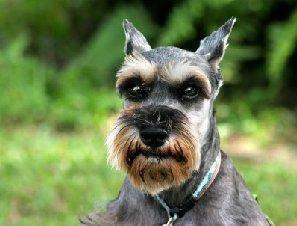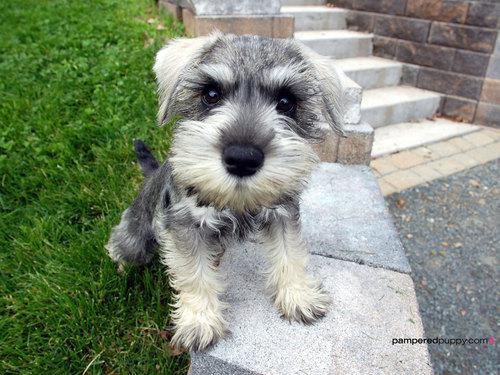The first image is the image on the left, the second image is the image on the right. Assess this claim about the two images: "The dogs in both images are looking forward.". Correct or not? Answer yes or no. Yes. 